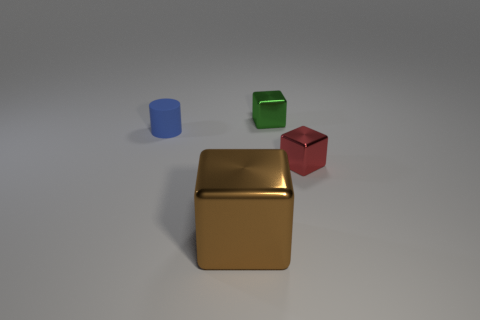Is there any other thing that has the same material as the small cylinder?
Provide a short and direct response. No. Is the material of the tiny cylinder the same as the tiny cube that is behind the blue cylinder?
Your answer should be very brief. No. Are there the same number of tiny blue matte cylinders that are in front of the tiny blue matte cylinder and brown things?
Your response must be concise. No. What color is the tiny thing that is to the left of the big brown metal block?
Provide a succinct answer. Blue. Is there anything else that is the same size as the red metal thing?
Ensure brevity in your answer.  Yes. There is a block that is in front of the red cube; is it the same size as the red cube?
Your response must be concise. No. What material is the tiny cube on the right side of the green object?
Provide a succinct answer. Metal. Is there anything else that is the same shape as the tiny green thing?
Your answer should be compact. Yes. How many matte objects are either red things or small yellow things?
Make the answer very short. 0. Is the number of tiny green blocks that are in front of the brown metallic cube less than the number of tiny blue metal spheres?
Provide a short and direct response. No. 